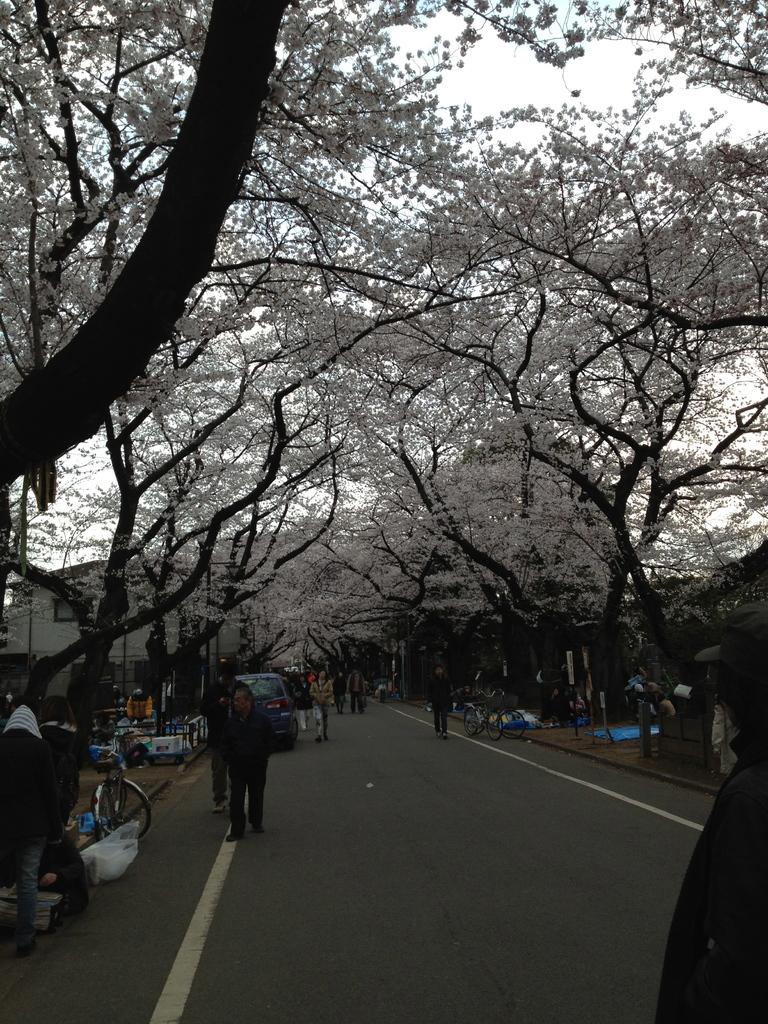What is the main subject of the image? The main subject of the image is a view of a road lane. What can be seen on the road? There are men and women walking on the road. What type of vegetation is present along the road? There are white color flower trees on both sides of the road. Can you tell me how many grapes are hanging from the trees in the image? There are no grapes present in the image; the trees have white color flowers. What type of net is being used to catch the people walking on the road? There is no net present in the image, and the people are walking freely on the road. 